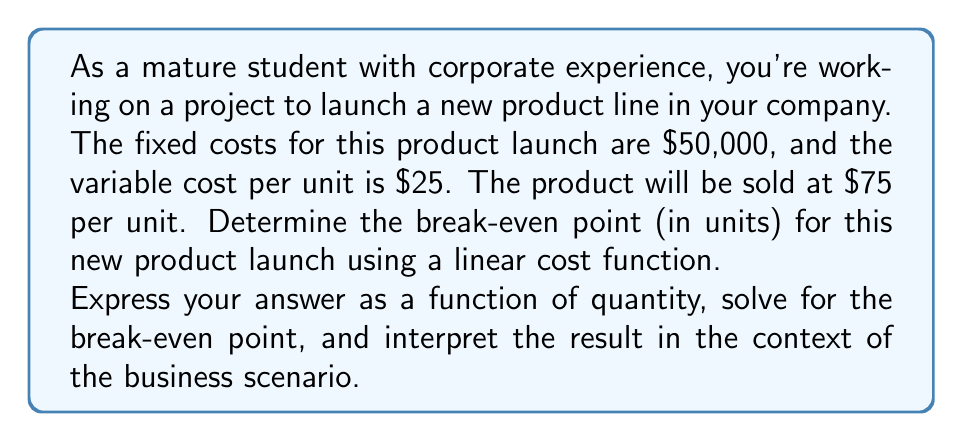Solve this math problem. Let's approach this step-by-step:

1) First, let's define our variables:
   $q$ = quantity of units
   $R(q)$ = Revenue function
   $C(q)$ = Cost function
   $P(q)$ = Profit function

2) Now, let's set up our functions:

   Revenue function: $R(q) = 75q$ (price per unit × quantity)
   Cost function: $C(q) = 50000 + 25q$ (fixed costs + variable cost per unit × quantity)

3) The profit function is the difference between revenue and cost:

   $P(q) = R(q) - C(q) = 75q - (50000 + 25q) = 75q - 50000 - 25q = 50q - 50000$

4) At the break-even point, profit is zero. So we set $P(q) = 0$:

   $50q - 50000 = 0$

5) Solve for $q$:

   $50q = 50000$
   $q = 1000$

6) To verify, let's plug this back into our revenue and cost functions:

   $R(1000) = 75 * 1000 = 75000$
   $C(1000) = 50000 + 25 * 1000 = 75000$

   Indeed, at 1000 units, revenue equals costs, confirming the break-even point.

Interpretation: The company needs to sell 1000 units of the new product to break even. At this point, the total revenue will equal the total costs at $75,000. Any sales beyond 1000 units will generate profit, while selling fewer than 1000 units will result in a loss.
Answer: The break-even point is 1000 units. The break-even function can be expressed as:

$P(q) = 50q - 50000$

where $P(q)$ is the profit function and $q$ is the quantity of units sold. When $P(q) = 0$, $q = 1000$, which is the break-even point. 